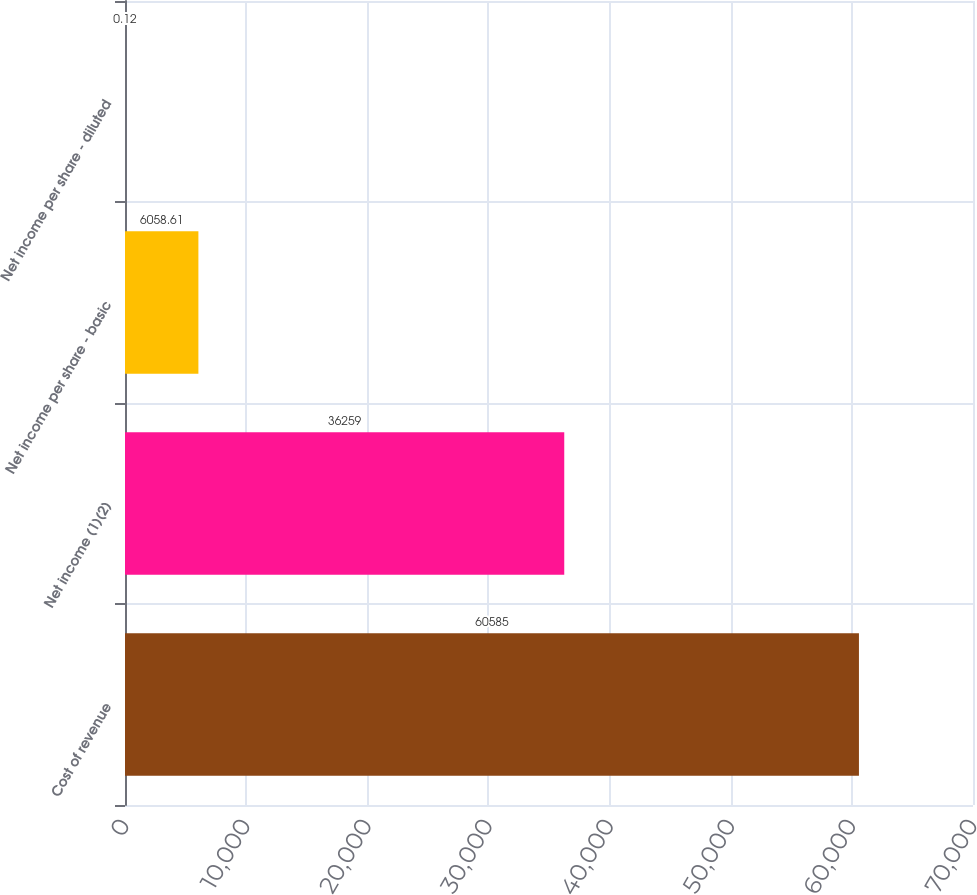<chart> <loc_0><loc_0><loc_500><loc_500><bar_chart><fcel>Cost of revenue<fcel>Net income (1)(2)<fcel>Net income per share - basic<fcel>Net income per share - diluted<nl><fcel>60585<fcel>36259<fcel>6058.61<fcel>0.12<nl></chart> 